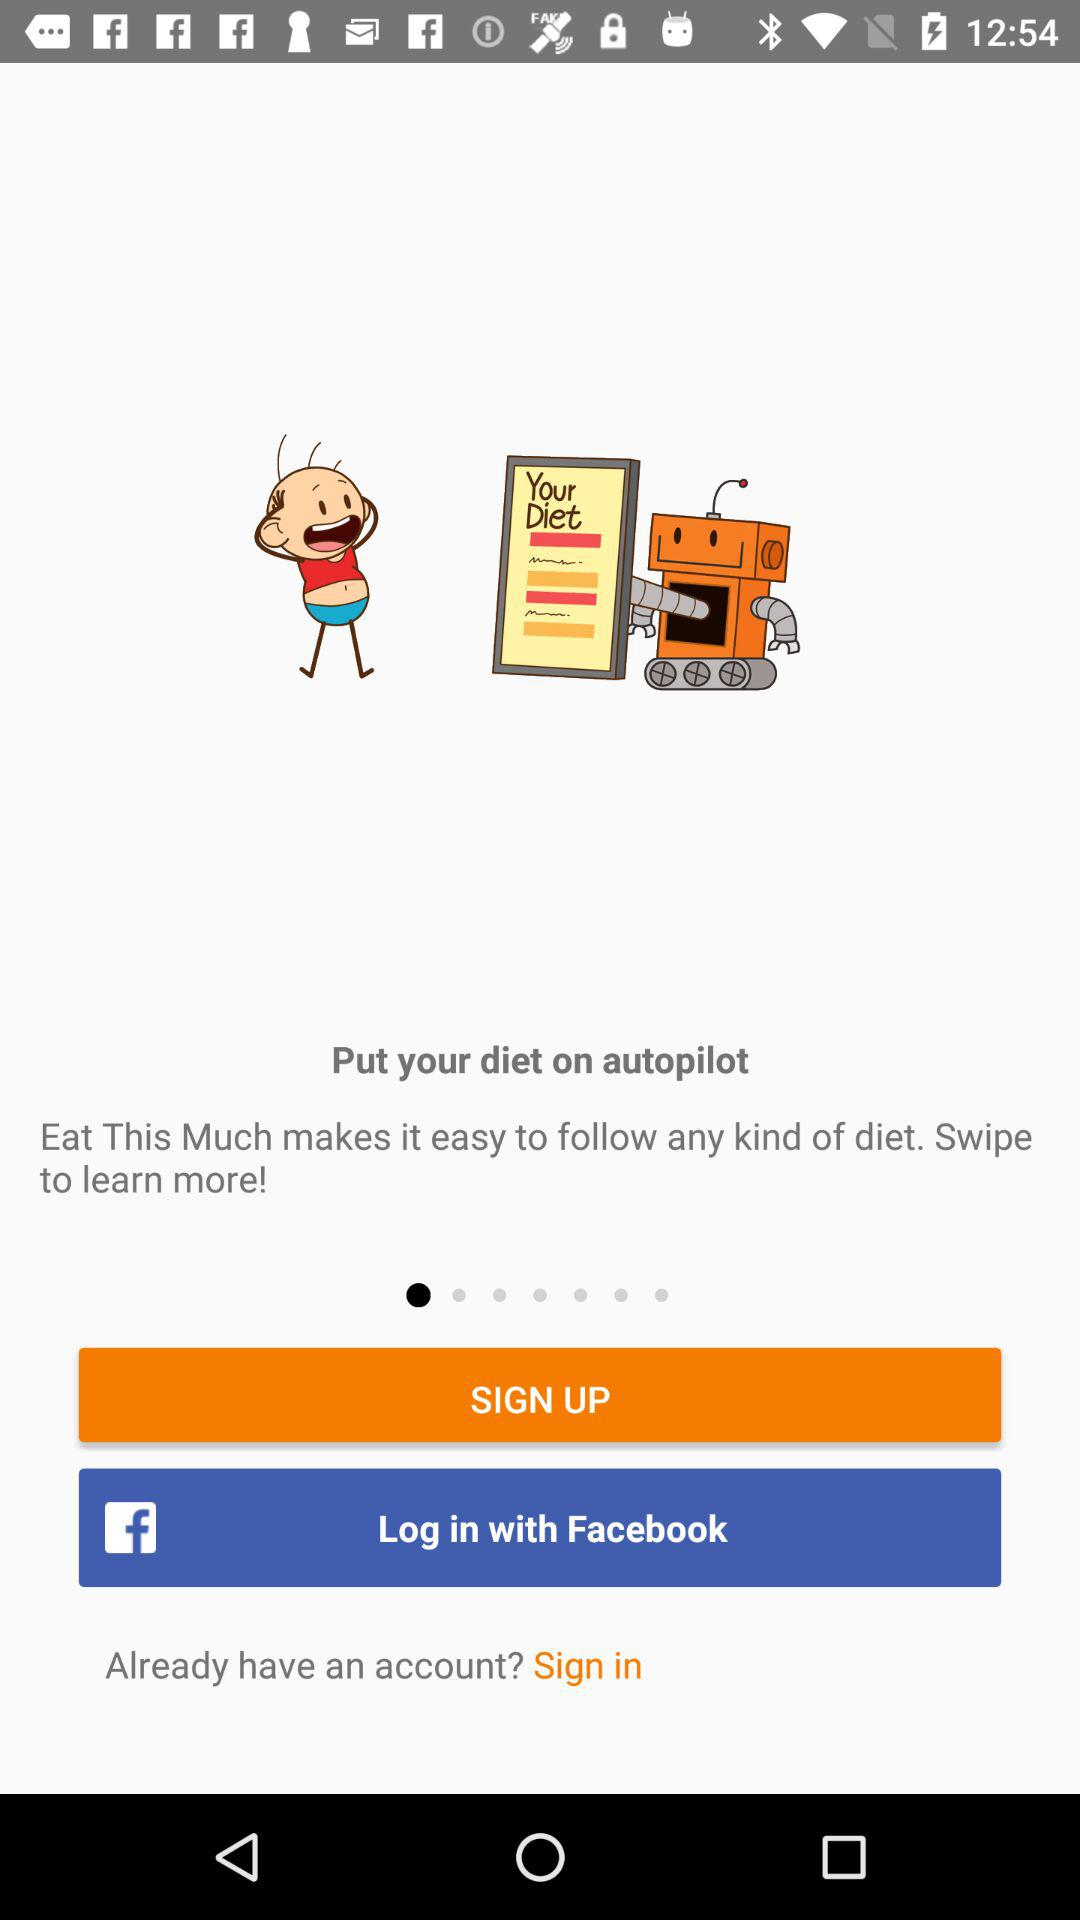What is the application name? The application name is "Eat This Much". 